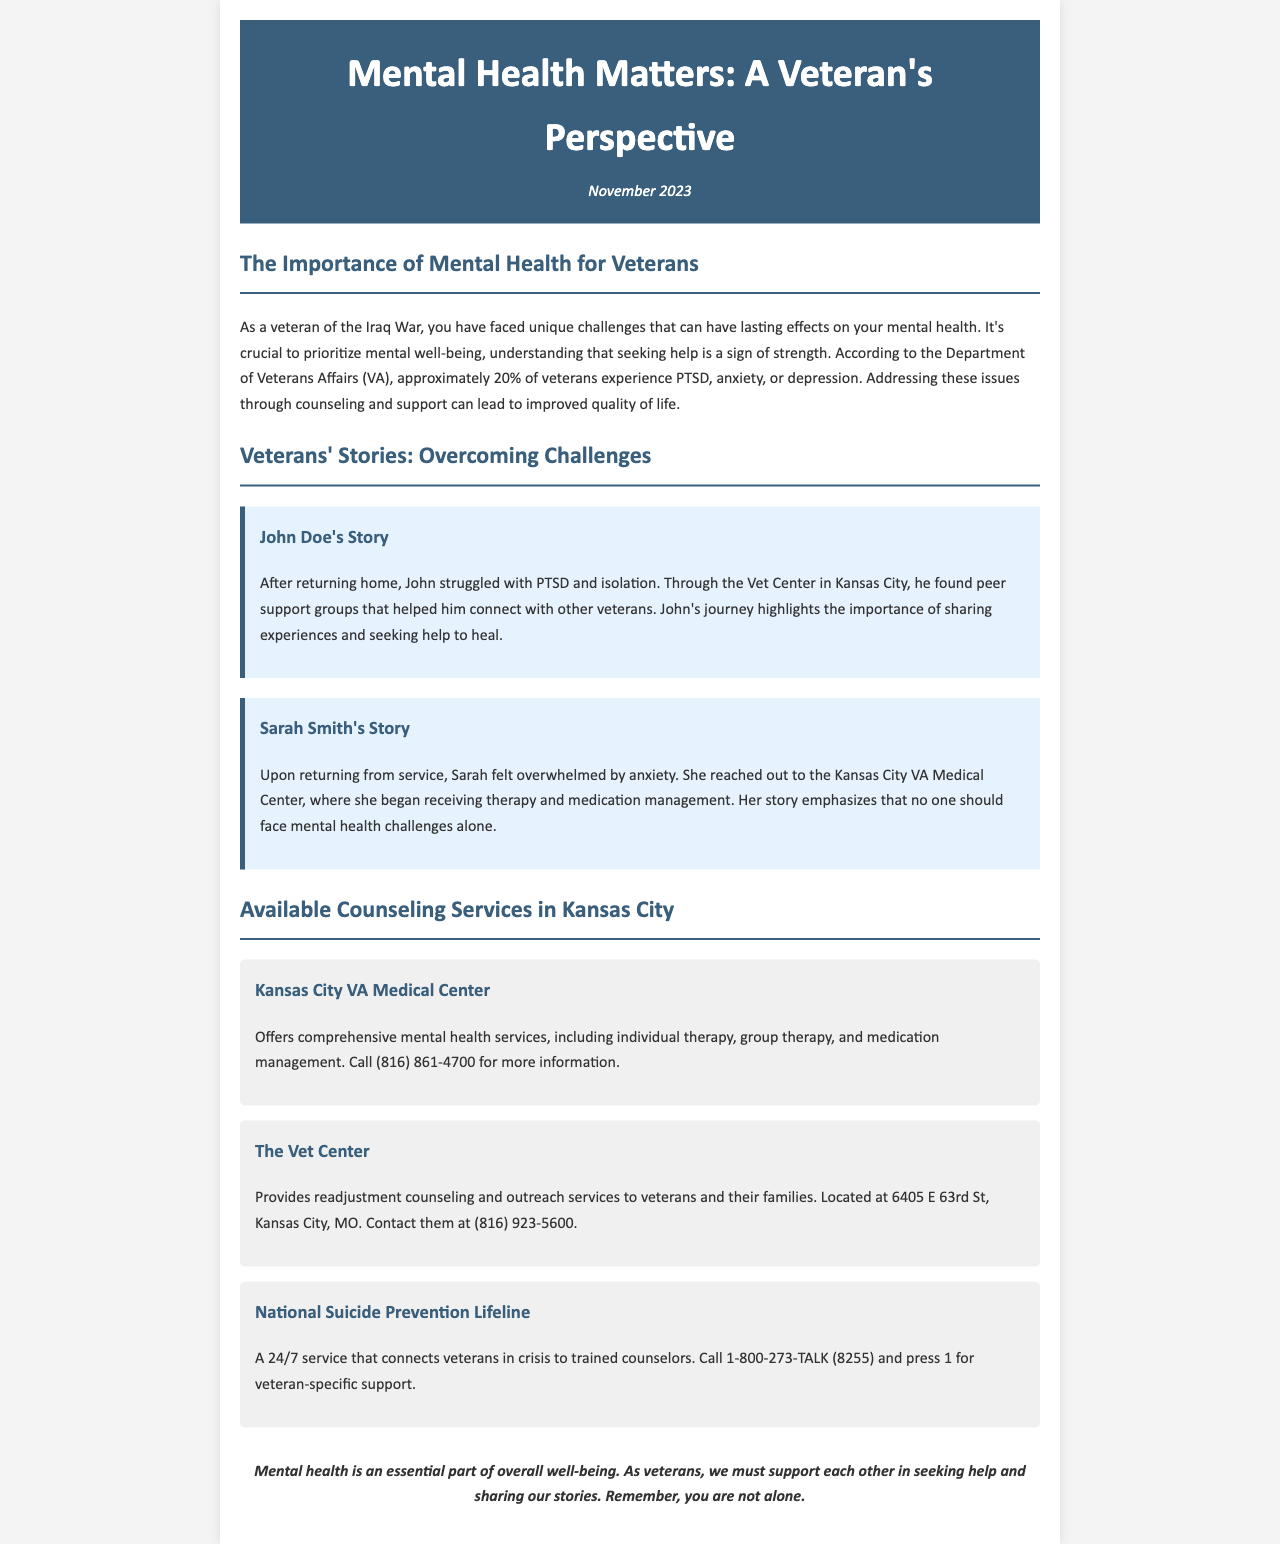What percentage of veterans experience PTSD, anxiety, or depression? The document states that approximately 20% of veterans experience these conditions.
Answer: 20% Who struggled with PTSD and isolation? John Doe's story highlights his struggle with PTSD and isolation after returning home.
Answer: John Doe What is the address of The Vet Center? The document provides the location as 6405 E 63rd St, Kansas City, MO.
Answer: 6405 E 63rd St, Kansas City, MO What type of counseling does the Kansas City VA Medical Center offer? The document lists individual therapy, group therapy, and medication management as services.
Answer: Comprehensive mental health services What number should veterans call for the National Suicide Prevention Lifeline? The document provides the number as 1-800-273-TALK (8255) and instructs to press 1 for veteran-specific support.
Answer: 1-800-273-TALK (8255) What does Sarah Smith's story emphasize? Her story emphasizes that no one should face mental health challenges alone.
Answer: No one should face mental health challenges alone How does the document suggest veterans can support each other? It suggests supporting each other in seeking help and sharing stories.
Answer: Seeking help and sharing stories 